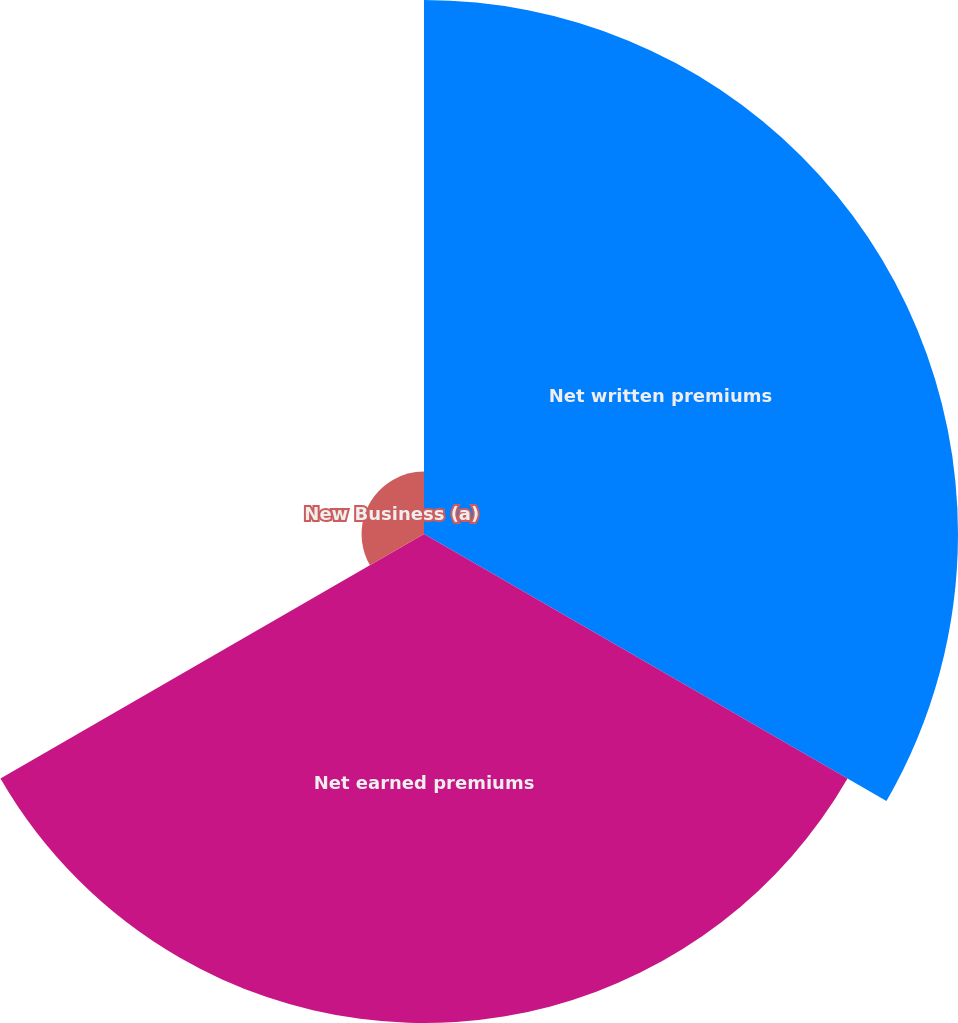<chart> <loc_0><loc_0><loc_500><loc_500><pie_chart><fcel>Net written premiums<fcel>Net earned premiums<fcel>New Business (a)<nl><fcel>49.19%<fcel>45.05%<fcel>5.75%<nl></chart> 